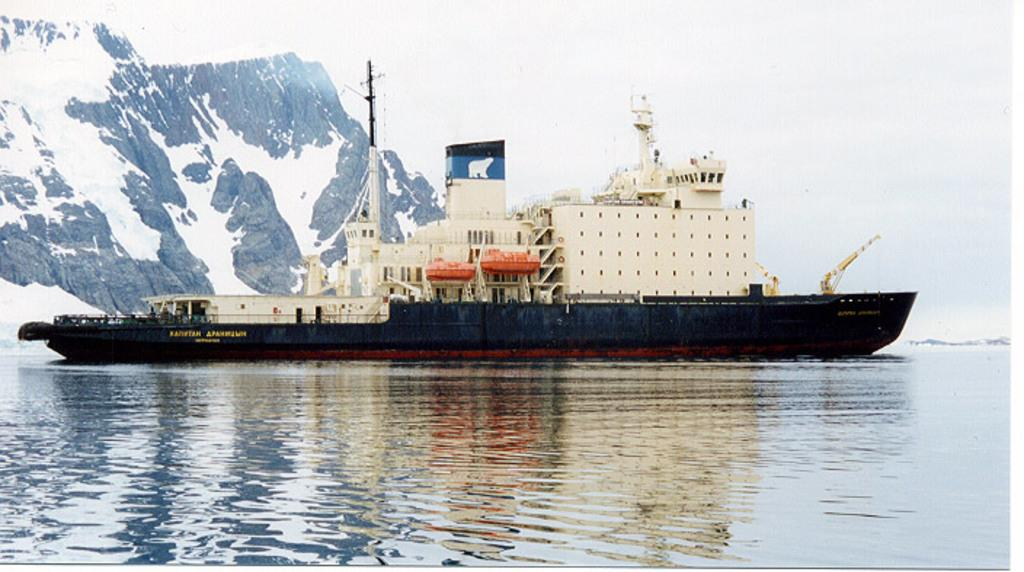What is the main subject in the center of the image? There is a ship in the center of the image. Where is the ship located? The ship is on the water. What can be seen in the background of the image? There is a mountain and the sky visible in the background of the image. What type of apparel is the ship wearing in the image? Ships do not wear apparel; the question is not applicable to the image. 